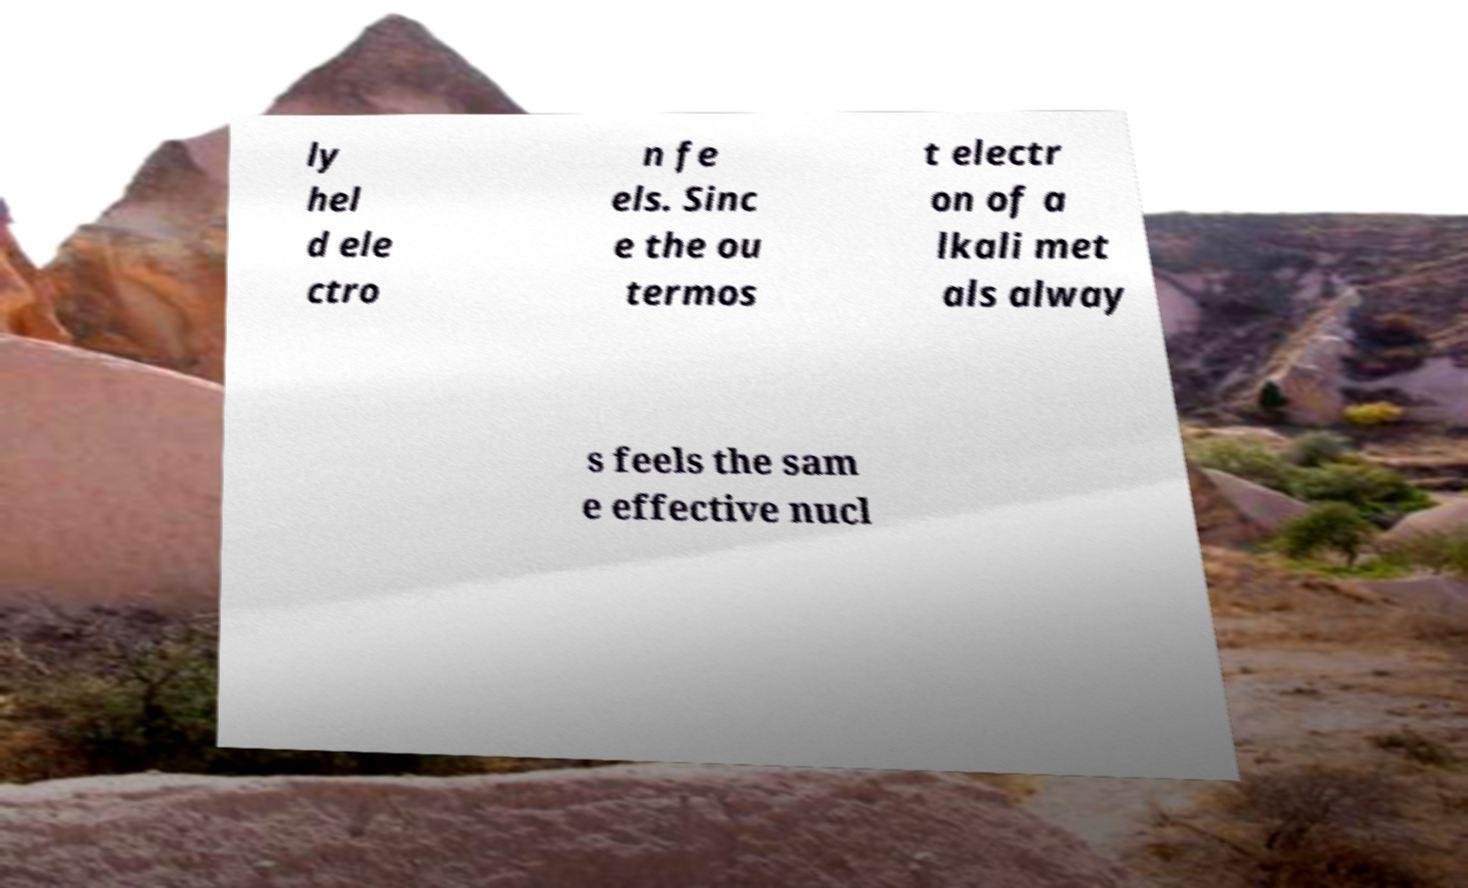Can you accurately transcribe the text from the provided image for me? ly hel d ele ctro n fe els. Sinc e the ou termos t electr on of a lkali met als alway s feels the sam e effective nucl 